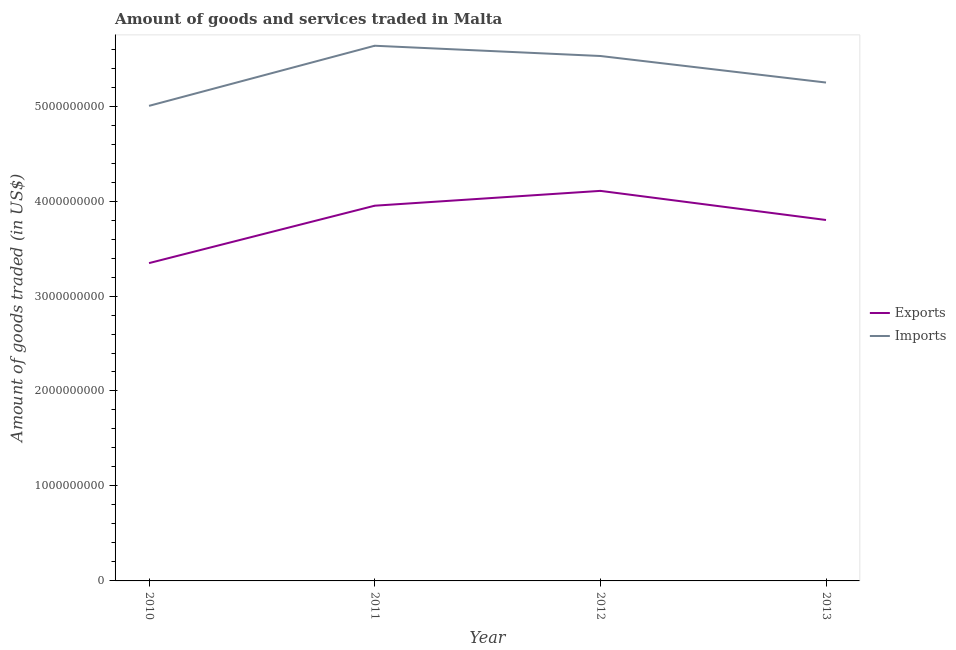Does the line corresponding to amount of goods imported intersect with the line corresponding to amount of goods exported?
Provide a short and direct response. No. Is the number of lines equal to the number of legend labels?
Give a very brief answer. Yes. What is the amount of goods exported in 2012?
Provide a short and direct response. 4.11e+09. Across all years, what is the maximum amount of goods imported?
Your response must be concise. 5.64e+09. Across all years, what is the minimum amount of goods exported?
Your answer should be compact. 3.35e+09. In which year was the amount of goods exported maximum?
Your response must be concise. 2012. In which year was the amount of goods exported minimum?
Offer a very short reply. 2010. What is the total amount of goods imported in the graph?
Provide a short and direct response. 2.14e+1. What is the difference between the amount of goods imported in 2011 and that in 2013?
Offer a very short reply. 3.87e+08. What is the difference between the amount of goods imported in 2013 and the amount of goods exported in 2010?
Provide a succinct answer. 1.90e+09. What is the average amount of goods exported per year?
Provide a succinct answer. 3.80e+09. In the year 2013, what is the difference between the amount of goods imported and amount of goods exported?
Offer a very short reply. 1.45e+09. What is the ratio of the amount of goods exported in 2011 to that in 2013?
Your answer should be very brief. 1.04. Is the difference between the amount of goods imported in 2010 and 2011 greater than the difference between the amount of goods exported in 2010 and 2011?
Your answer should be very brief. No. What is the difference between the highest and the second highest amount of goods imported?
Your response must be concise. 1.08e+08. What is the difference between the highest and the lowest amount of goods exported?
Your answer should be compact. 7.61e+08. Is the sum of the amount of goods exported in 2011 and 2013 greater than the maximum amount of goods imported across all years?
Your answer should be compact. Yes. How many lines are there?
Your answer should be very brief. 2. Does the graph contain any zero values?
Make the answer very short. No. Where does the legend appear in the graph?
Provide a short and direct response. Center right. How many legend labels are there?
Ensure brevity in your answer.  2. How are the legend labels stacked?
Make the answer very short. Vertical. What is the title of the graph?
Provide a short and direct response. Amount of goods and services traded in Malta. What is the label or title of the Y-axis?
Provide a short and direct response. Amount of goods traded (in US$). What is the Amount of goods traded (in US$) in Exports in 2010?
Offer a terse response. 3.35e+09. What is the Amount of goods traded (in US$) in Imports in 2010?
Your answer should be very brief. 5.00e+09. What is the Amount of goods traded (in US$) of Exports in 2011?
Make the answer very short. 3.95e+09. What is the Amount of goods traded (in US$) of Imports in 2011?
Offer a terse response. 5.64e+09. What is the Amount of goods traded (in US$) of Exports in 2012?
Offer a very short reply. 4.11e+09. What is the Amount of goods traded (in US$) of Imports in 2012?
Keep it short and to the point. 5.53e+09. What is the Amount of goods traded (in US$) of Exports in 2013?
Provide a succinct answer. 3.80e+09. What is the Amount of goods traded (in US$) of Imports in 2013?
Give a very brief answer. 5.25e+09. Across all years, what is the maximum Amount of goods traded (in US$) of Exports?
Keep it short and to the point. 4.11e+09. Across all years, what is the maximum Amount of goods traded (in US$) of Imports?
Ensure brevity in your answer.  5.64e+09. Across all years, what is the minimum Amount of goods traded (in US$) in Exports?
Make the answer very short. 3.35e+09. Across all years, what is the minimum Amount of goods traded (in US$) in Imports?
Offer a terse response. 5.00e+09. What is the total Amount of goods traded (in US$) of Exports in the graph?
Give a very brief answer. 1.52e+1. What is the total Amount of goods traded (in US$) of Imports in the graph?
Keep it short and to the point. 2.14e+1. What is the difference between the Amount of goods traded (in US$) in Exports in 2010 and that in 2011?
Offer a terse response. -6.04e+08. What is the difference between the Amount of goods traded (in US$) of Imports in 2010 and that in 2011?
Make the answer very short. -6.33e+08. What is the difference between the Amount of goods traded (in US$) of Exports in 2010 and that in 2012?
Your answer should be compact. -7.61e+08. What is the difference between the Amount of goods traded (in US$) of Imports in 2010 and that in 2012?
Provide a succinct answer. -5.25e+08. What is the difference between the Amount of goods traded (in US$) of Exports in 2010 and that in 2013?
Your answer should be compact. -4.54e+08. What is the difference between the Amount of goods traded (in US$) of Imports in 2010 and that in 2013?
Offer a terse response. -2.46e+08. What is the difference between the Amount of goods traded (in US$) of Exports in 2011 and that in 2012?
Give a very brief answer. -1.56e+08. What is the difference between the Amount of goods traded (in US$) of Imports in 2011 and that in 2012?
Give a very brief answer. 1.08e+08. What is the difference between the Amount of goods traded (in US$) in Exports in 2011 and that in 2013?
Make the answer very short. 1.51e+08. What is the difference between the Amount of goods traded (in US$) in Imports in 2011 and that in 2013?
Offer a very short reply. 3.87e+08. What is the difference between the Amount of goods traded (in US$) of Exports in 2012 and that in 2013?
Make the answer very short. 3.07e+08. What is the difference between the Amount of goods traded (in US$) in Imports in 2012 and that in 2013?
Make the answer very short. 2.79e+08. What is the difference between the Amount of goods traded (in US$) in Exports in 2010 and the Amount of goods traded (in US$) in Imports in 2011?
Offer a terse response. -2.29e+09. What is the difference between the Amount of goods traded (in US$) of Exports in 2010 and the Amount of goods traded (in US$) of Imports in 2012?
Your response must be concise. -2.18e+09. What is the difference between the Amount of goods traded (in US$) in Exports in 2010 and the Amount of goods traded (in US$) in Imports in 2013?
Your answer should be very brief. -1.90e+09. What is the difference between the Amount of goods traded (in US$) in Exports in 2011 and the Amount of goods traded (in US$) in Imports in 2012?
Offer a very short reply. -1.58e+09. What is the difference between the Amount of goods traded (in US$) in Exports in 2011 and the Amount of goods traded (in US$) in Imports in 2013?
Offer a terse response. -1.30e+09. What is the difference between the Amount of goods traded (in US$) of Exports in 2012 and the Amount of goods traded (in US$) of Imports in 2013?
Your response must be concise. -1.14e+09. What is the average Amount of goods traded (in US$) of Exports per year?
Your answer should be very brief. 3.80e+09. What is the average Amount of goods traded (in US$) in Imports per year?
Offer a very short reply. 5.35e+09. In the year 2010, what is the difference between the Amount of goods traded (in US$) of Exports and Amount of goods traded (in US$) of Imports?
Your answer should be very brief. -1.66e+09. In the year 2011, what is the difference between the Amount of goods traded (in US$) in Exports and Amount of goods traded (in US$) in Imports?
Your answer should be very brief. -1.68e+09. In the year 2012, what is the difference between the Amount of goods traded (in US$) in Exports and Amount of goods traded (in US$) in Imports?
Ensure brevity in your answer.  -1.42e+09. In the year 2013, what is the difference between the Amount of goods traded (in US$) in Exports and Amount of goods traded (in US$) in Imports?
Provide a short and direct response. -1.45e+09. What is the ratio of the Amount of goods traded (in US$) of Exports in 2010 to that in 2011?
Your answer should be very brief. 0.85. What is the ratio of the Amount of goods traded (in US$) of Imports in 2010 to that in 2011?
Make the answer very short. 0.89. What is the ratio of the Amount of goods traded (in US$) in Exports in 2010 to that in 2012?
Your answer should be very brief. 0.81. What is the ratio of the Amount of goods traded (in US$) of Imports in 2010 to that in 2012?
Make the answer very short. 0.91. What is the ratio of the Amount of goods traded (in US$) in Exports in 2010 to that in 2013?
Provide a short and direct response. 0.88. What is the ratio of the Amount of goods traded (in US$) of Imports in 2010 to that in 2013?
Keep it short and to the point. 0.95. What is the ratio of the Amount of goods traded (in US$) in Imports in 2011 to that in 2012?
Provide a short and direct response. 1.02. What is the ratio of the Amount of goods traded (in US$) of Exports in 2011 to that in 2013?
Give a very brief answer. 1.04. What is the ratio of the Amount of goods traded (in US$) in Imports in 2011 to that in 2013?
Your response must be concise. 1.07. What is the ratio of the Amount of goods traded (in US$) of Exports in 2012 to that in 2013?
Offer a very short reply. 1.08. What is the ratio of the Amount of goods traded (in US$) of Imports in 2012 to that in 2013?
Provide a succinct answer. 1.05. What is the difference between the highest and the second highest Amount of goods traded (in US$) of Exports?
Offer a very short reply. 1.56e+08. What is the difference between the highest and the second highest Amount of goods traded (in US$) of Imports?
Offer a very short reply. 1.08e+08. What is the difference between the highest and the lowest Amount of goods traded (in US$) of Exports?
Give a very brief answer. 7.61e+08. What is the difference between the highest and the lowest Amount of goods traded (in US$) in Imports?
Offer a very short reply. 6.33e+08. 